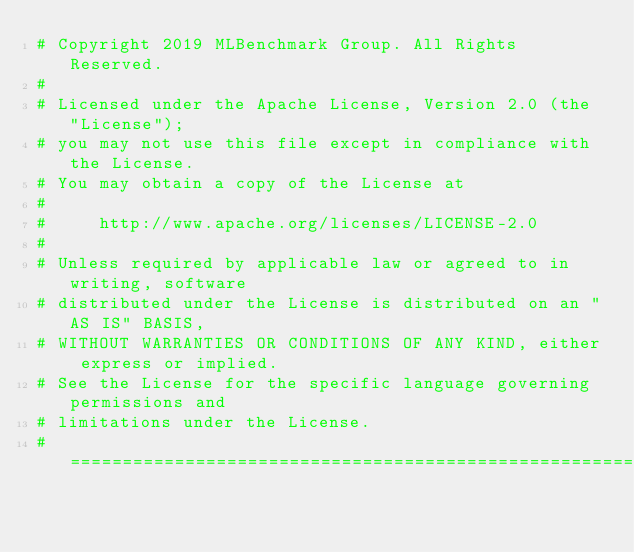Convert code to text. <code><loc_0><loc_0><loc_500><loc_500><_Python_># Copyright 2019 MLBenchmark Group. All Rights Reserved.
#
# Licensed under the Apache License, Version 2.0 (the "License");
# you may not use this file except in compliance with the License.
# You may obtain a copy of the License at
#
#     http://www.apache.org/licenses/LICENSE-2.0
#
# Unless required by applicable law or agreed to in writing, software
# distributed under the License is distributed on an "AS IS" BASIS,
# WITHOUT WARRANTIES OR CONDITIONS OF ANY KIND, either express or implied.
# See the License for the specific language governing permissions and
# limitations under the License.
# ==============================================================================
</code> 